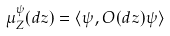Convert formula to latex. <formula><loc_0><loc_0><loc_500><loc_500>\mu _ { Z } ^ { \psi } ( d z ) = \langle \psi , O ( d z ) \psi \rangle</formula> 